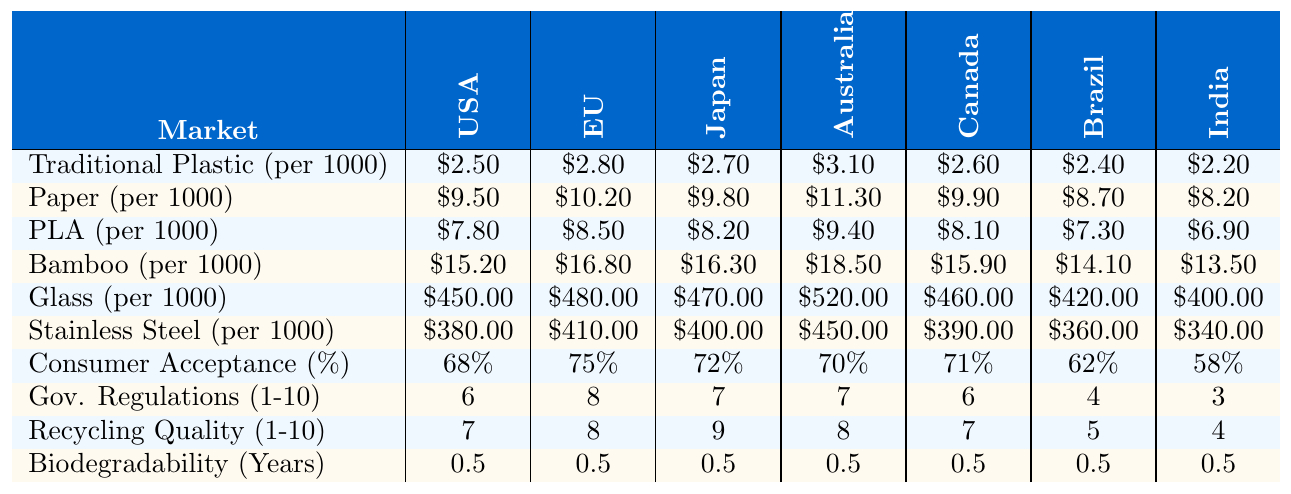What is the cost of traditional plastic straws in Canada? The table shows that the cost of traditional plastic straws in Canada is listed as $2.60 for 1000 units.
Answer: $2.60 Which sustainable option is the cheapest per 1000 units in the United States? Among the sustainable options listed, PLA straws cost $7.80, paper straws cost $9.50, bamboo straws cost $15.20, glass straws are substantially more expensive at $450.00, and stainless steel straws are also high at $380.00. Thus, PLA straws are the cheapest.
Answer: PLA straws at $7.80 What is the average consumer acceptance percentage for sustainable options across all markets? To find the average, sum all consumer acceptance percentages: (68 + 75 + 72 + 70 + 71 + 62 + 58) = 476. There are 7 markets, so the average is 476 / 7 ≈ 68. That's approximately 68% consumer acceptance.
Answer: 68% How much more do bamboo straws cost compared to traditional plastic straws in Brazil? The cost of bamboo straws is $14.10 per 1000 units, and traditional plastic straws cost $2.40 per 1000 units in Brazil. The difference is $14.10 - $2.40 = $11.70, indicating bamboo straws are significantly more expensive.
Answer: $11.70 Are government regulations on plastic straws higher in the EU compared to India? The EU has a government regulation score of 8, while India has a score of 3. Since 8 is greater than 3, regulations are indeed higher in the EU.
Answer: Yes What is the difference in recycling infrastructure quality between Japan and Brazil? Japan has a recycling infrastructure quality score of 9, while Brazil has a score of 5. The difference is 9 - 5 = 4. Therefore, Japan has a better recycling infrastructure.
Answer: 4 Which market has the highest cost for glass straws? By examining the table, Australia has the highest cost listed for glass straws at $520.00 for 1000 units.
Answer: Australia at $520.00 Which sustainable option has the lowest biodegradability, and what is its rating? All sustainable options listed have the same biodegradability rating of 0.5 years. Therefore, there is no unique lowest option; they all share the same value.
Answer: 0.5 years (same for all) Is consumer acceptance of sustainable options inversely related to the cost of traditional plastic straws across all markets? To assess the relationship, we analyze that as the cost of traditional plastic straw increases, consumer acceptance varies and does not show an absolute inverse relationship. For example, while Australia has the highest straw cost at $3.10, consumer acceptance is 70%, showing no clear inverse.
Answer: No 